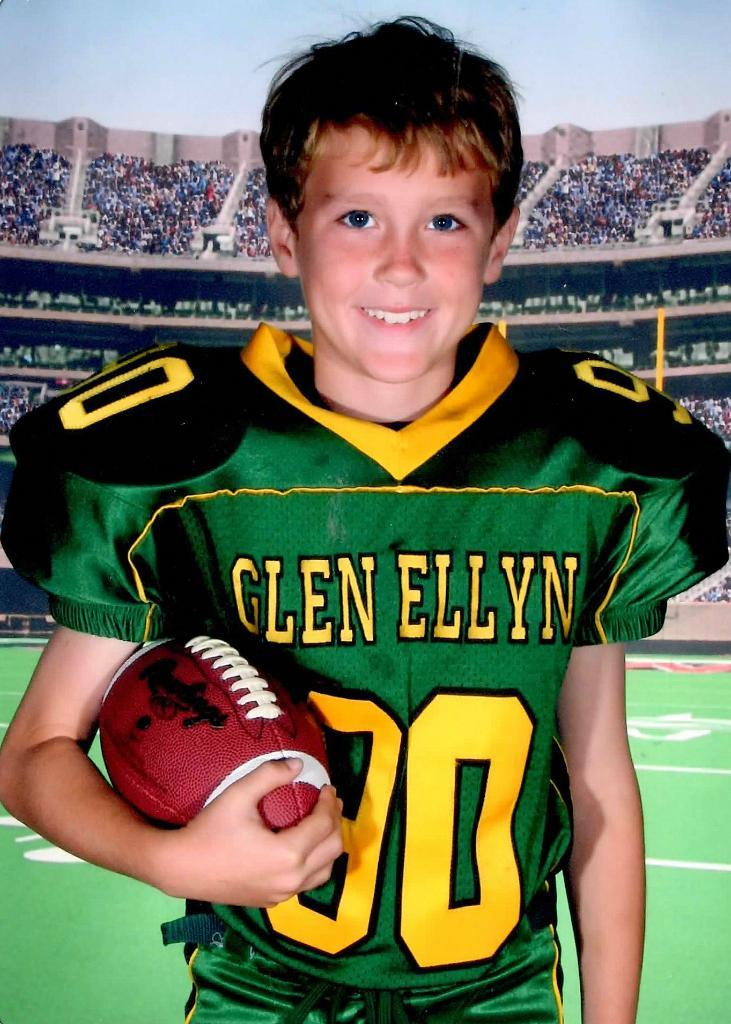<image>
Summarize the visual content of the image. the word Glen is on the front of the jersey 